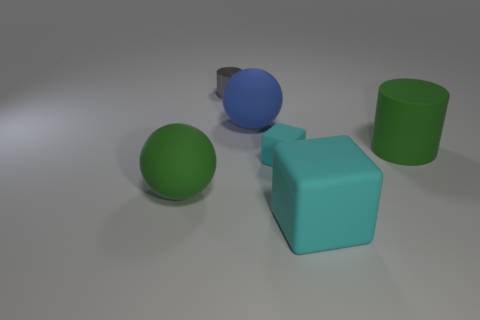Add 3 blue rubber spheres. How many objects exist? 9 Subtract all cylinders. How many objects are left? 4 Add 2 large rubber balls. How many large rubber balls are left? 4 Add 5 gray metal things. How many gray metal things exist? 6 Subtract 0 yellow blocks. How many objects are left? 6 Subtract all blue spheres. Subtract all green things. How many objects are left? 3 